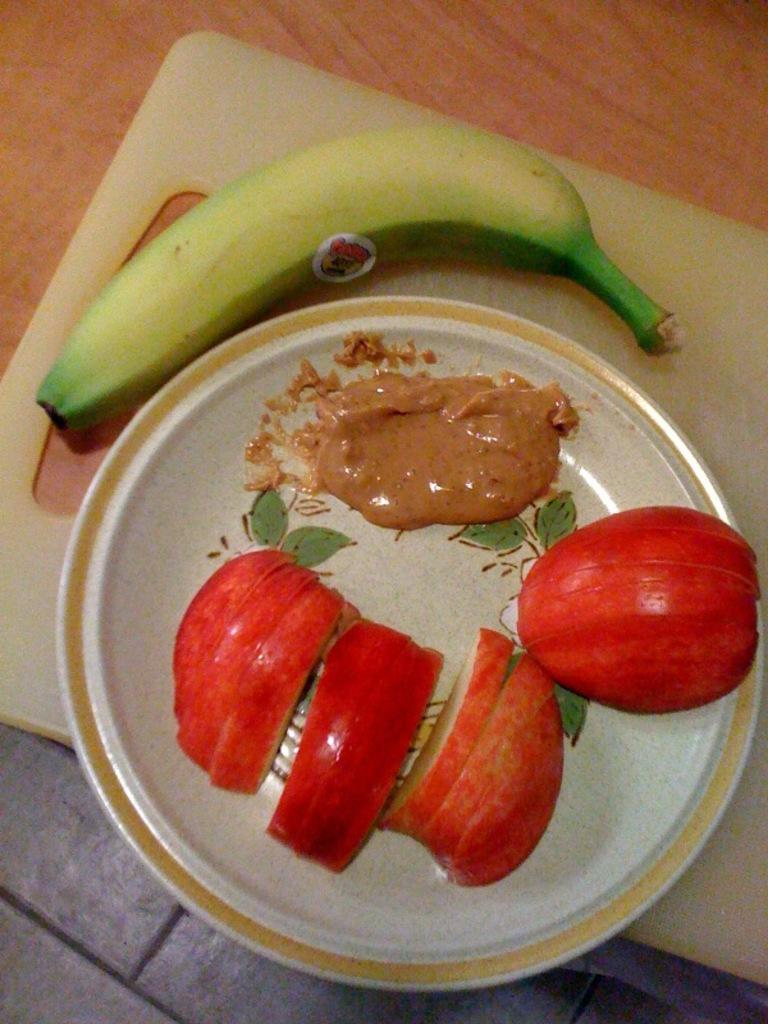What type of fruit can be seen on the plate in the image? There are slices of apple on a plate in the image. What else is on the plate besides the apple slices? There is sauce on the plate. What other fruit is visible in the image? There is a banana on a chopping board beside the plate. What type of skate is being used to cut the banana in the image? There is no skate present in the image, and the banana is not being cut. 